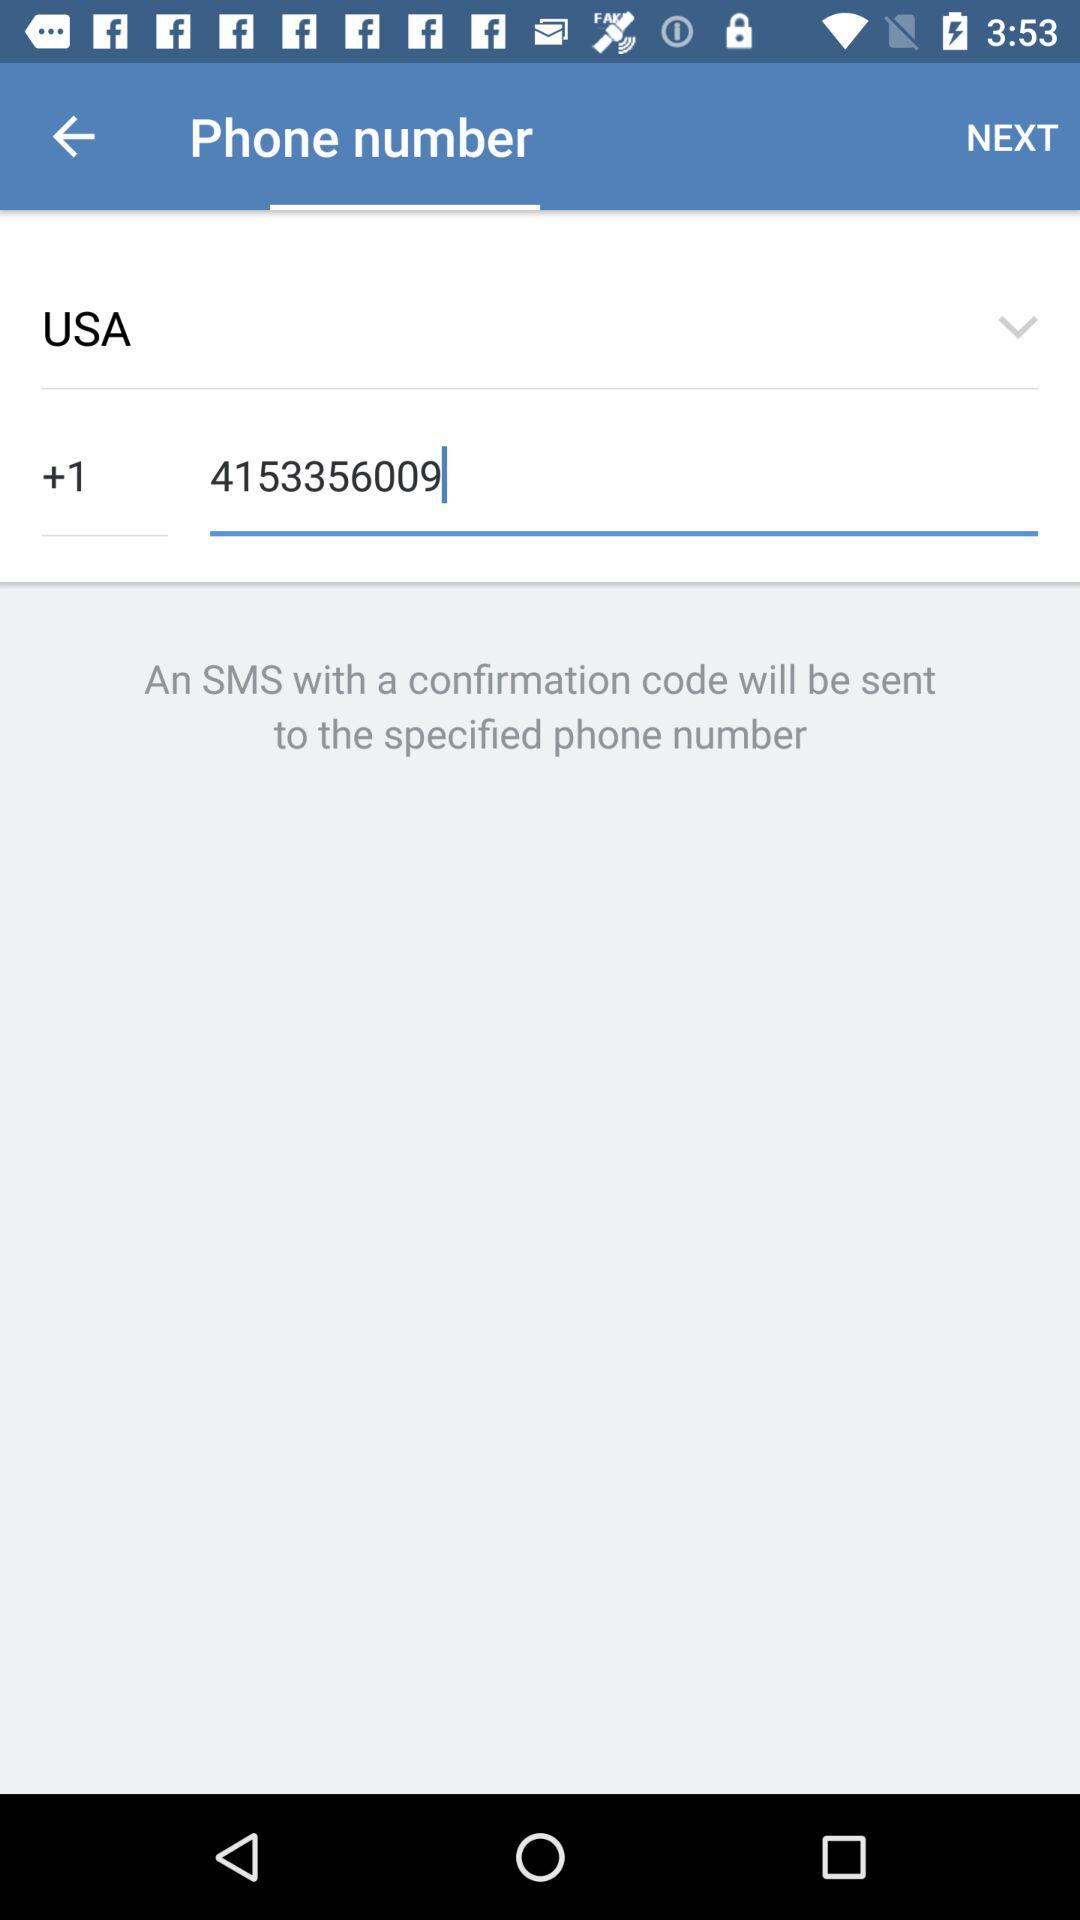How many digits are in the phone number field?
Answer the question using a single word or phrase. 10 